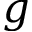<formula> <loc_0><loc_0><loc_500><loc_500>g</formula> 